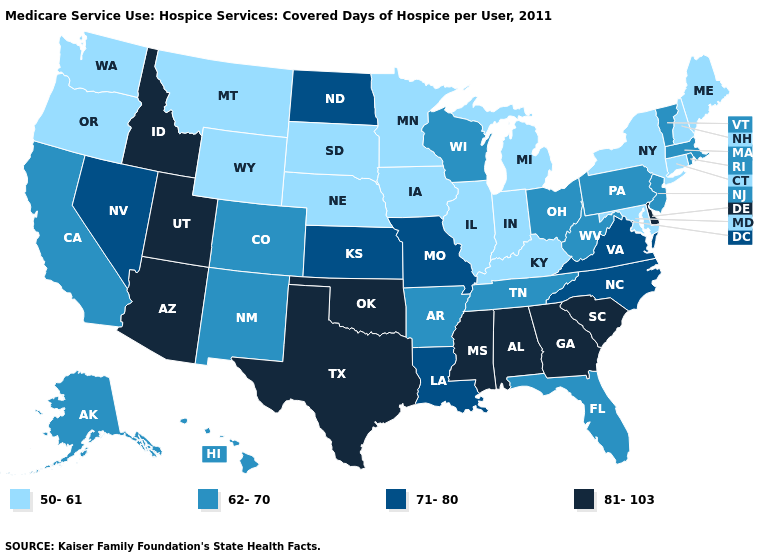Name the states that have a value in the range 62-70?
Short answer required. Alaska, Arkansas, California, Colorado, Florida, Hawaii, Massachusetts, New Jersey, New Mexico, Ohio, Pennsylvania, Rhode Island, Tennessee, Vermont, West Virginia, Wisconsin. Does Wisconsin have the lowest value in the MidWest?
Keep it brief. No. Does the first symbol in the legend represent the smallest category?
Quick response, please. Yes. Does Delaware have the highest value in the USA?
Keep it brief. Yes. Does Vermont have the same value as Maryland?
Short answer required. No. Name the states that have a value in the range 71-80?
Be succinct. Kansas, Louisiana, Missouri, Nevada, North Carolina, North Dakota, Virginia. What is the highest value in states that border South Dakota?
Concise answer only. 71-80. Does Texas have the highest value in the USA?
Be succinct. Yes. What is the highest value in the MidWest ?
Concise answer only. 71-80. What is the value of Texas?
Concise answer only. 81-103. How many symbols are there in the legend?
Write a very short answer. 4. What is the lowest value in the USA?
Keep it brief. 50-61. What is the value of Texas?
Be succinct. 81-103. What is the value of Rhode Island?
Quick response, please. 62-70. What is the lowest value in the USA?
Be succinct. 50-61. 